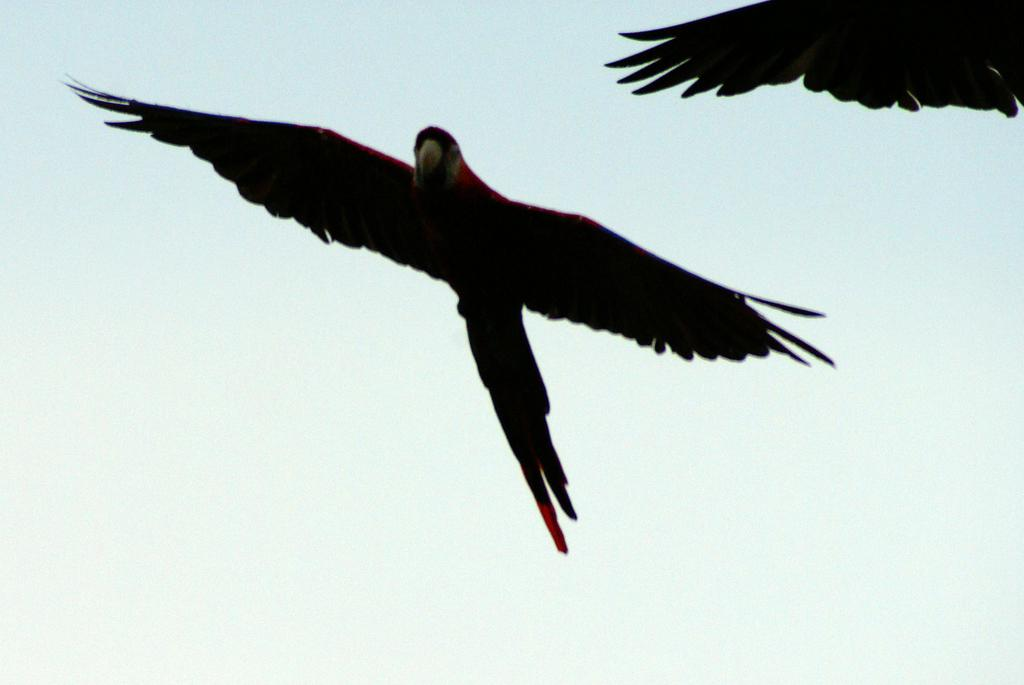How many birds are visible in the image? There are two birds in the image. What are the birds doing in the image? The birds are flying in the sky. What type of dolls can be seen hanging from the tree in the image? There is no tree or dolls present in the image; it features two birds flying in the sky. 